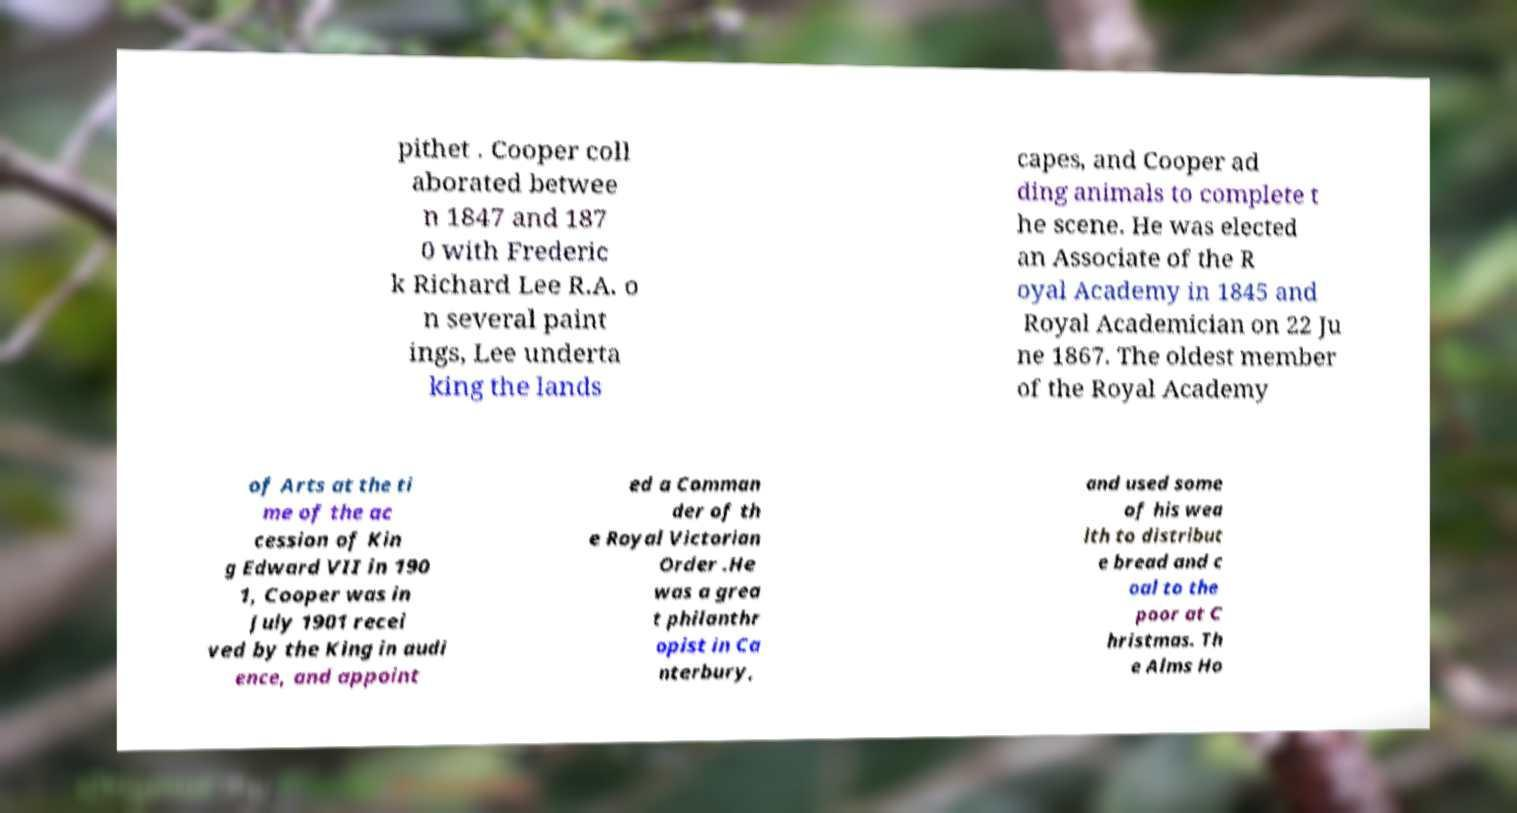Could you assist in decoding the text presented in this image and type it out clearly? pithet . Cooper coll aborated betwee n 1847 and 187 0 with Frederic k Richard Lee R.A. o n several paint ings, Lee underta king the lands capes, and Cooper ad ding animals to complete t he scene. He was elected an Associate of the R oyal Academy in 1845 and Royal Academician on 22 Ju ne 1867. The oldest member of the Royal Academy of Arts at the ti me of the ac cession of Kin g Edward VII in 190 1, Cooper was in July 1901 recei ved by the King in audi ence, and appoint ed a Comman der of th e Royal Victorian Order .He was a grea t philanthr opist in Ca nterbury, and used some of his wea lth to distribut e bread and c oal to the poor at C hristmas. Th e Alms Ho 